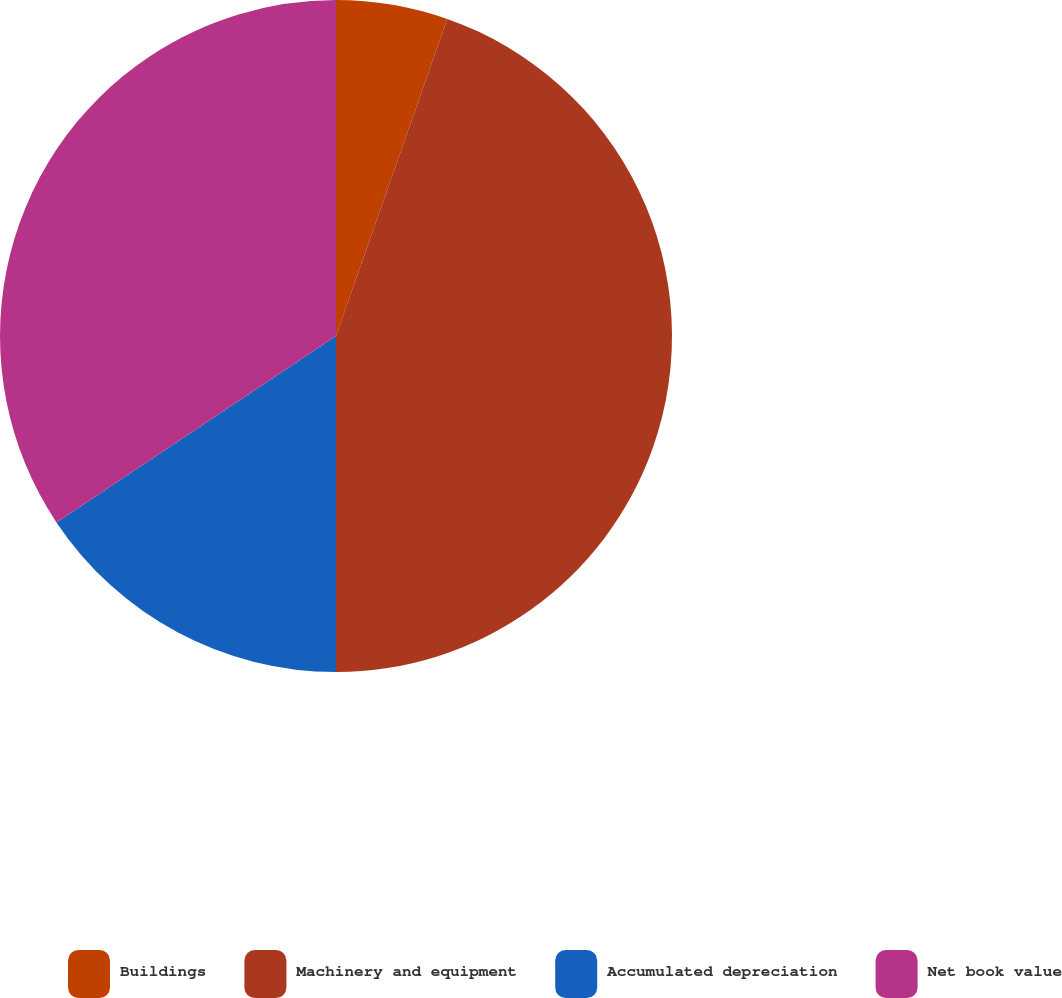<chart> <loc_0><loc_0><loc_500><loc_500><pie_chart><fcel>Buildings<fcel>Machinery and equipment<fcel>Accumulated depreciation<fcel>Net book value<nl><fcel>5.37%<fcel>44.63%<fcel>15.64%<fcel>34.36%<nl></chart> 